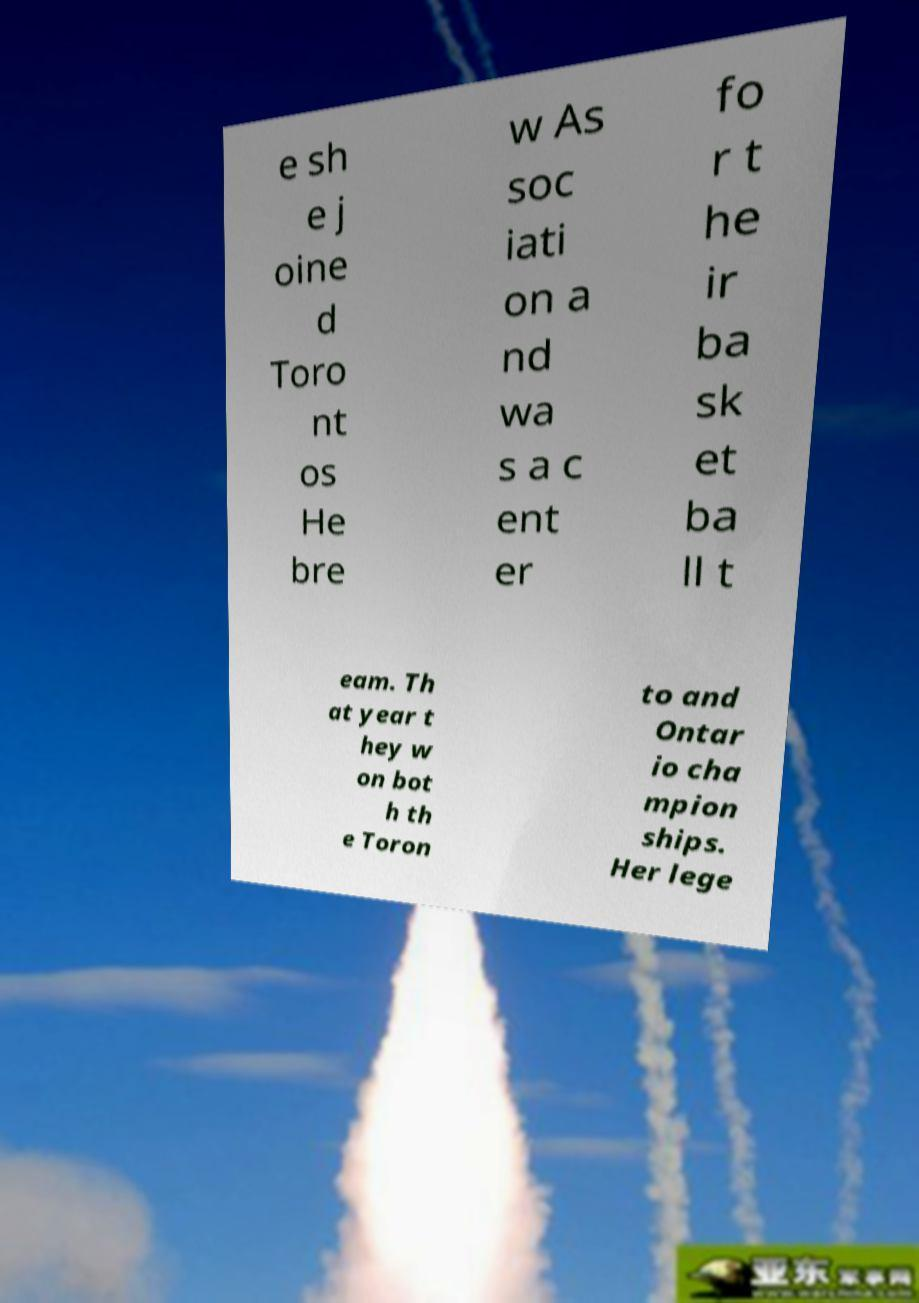Can you accurately transcribe the text from the provided image for me? e sh e j oine d Toro nt os He bre w As soc iati on a nd wa s a c ent er fo r t he ir ba sk et ba ll t eam. Th at year t hey w on bot h th e Toron to and Ontar io cha mpion ships. Her lege 